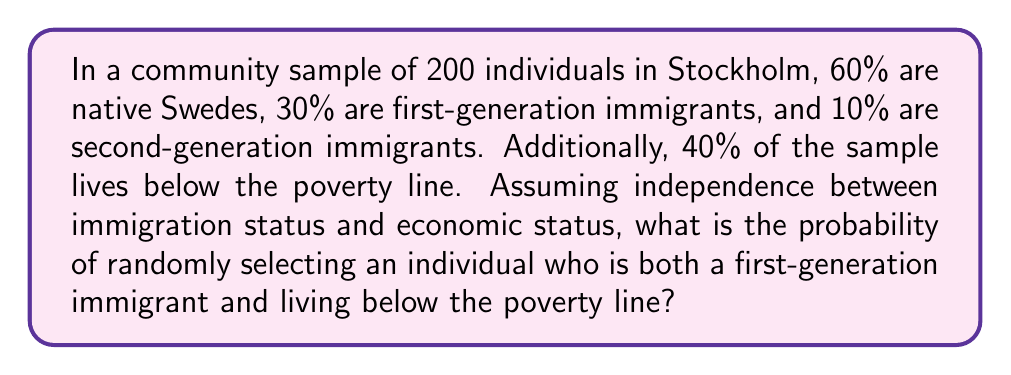Teach me how to tackle this problem. Let's approach this step-by-step:

1) First, we need to identify the probabilities of each event:
   
   P(First-generation immigrant) = 30% = 0.30
   P(Living below poverty line) = 40% = 0.40

2) The question assumes independence between immigration status and economic status. This means we can use the multiplication rule of probability for independent events.

3) The probability of both events occurring simultaneously is the product of their individual probabilities:

   $$P(\text{First-generation immigrant AND Below poverty line}) = P(\text{First-generation immigrant}) \times P(\text{Below poverty line})$$

4) Substituting the values:

   $$P(\text{First-generation immigrant AND Below poverty line}) = 0.30 \times 0.40$$

5) Calculating:

   $$P(\text{First-generation immigrant AND Below poverty line}) = 0.12$$

6) This can be expressed as a percentage:

   $$0.12 \times 100\% = 12\%$$

Thus, the probability of randomly selecting an individual who is both a first-generation immigrant and living below the poverty line is 12% or 0.12.
Answer: 0.12 